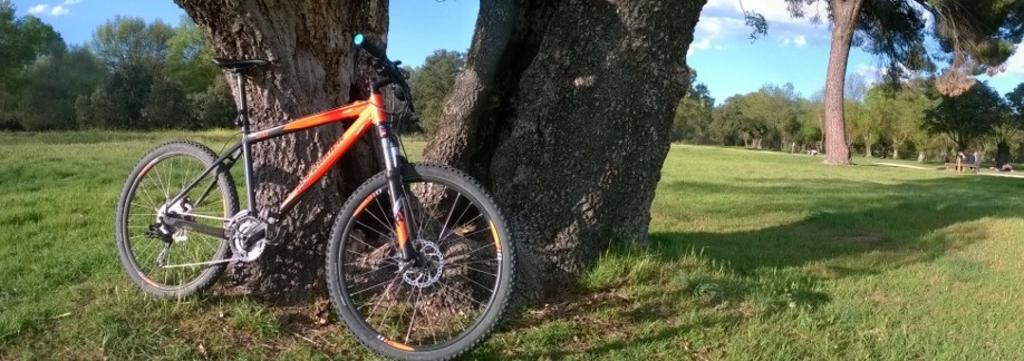What is the main subject of the image? The main subject of the image is a bicycle. What colors can be seen on the bicycle? The bicycle is black and orange in color. What type of natural environment is visible in the image? There are many trees in the image, indicating a natural environment. What can be seen in the background of the image? There are clouds and the sky visible in the background of the image. What type of letter is being written by the trees in the image? There are no trees writing letters in the image; they are simply part of the natural environment. 